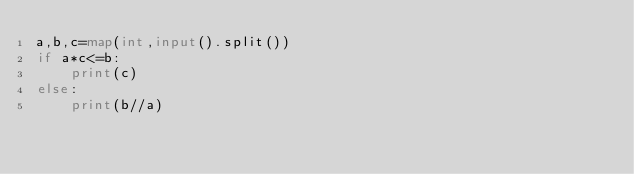<code> <loc_0><loc_0><loc_500><loc_500><_Python_>a,b,c=map(int,input().split())
if a*c<=b:
    print(c)
else:
    print(b//a)
</code> 